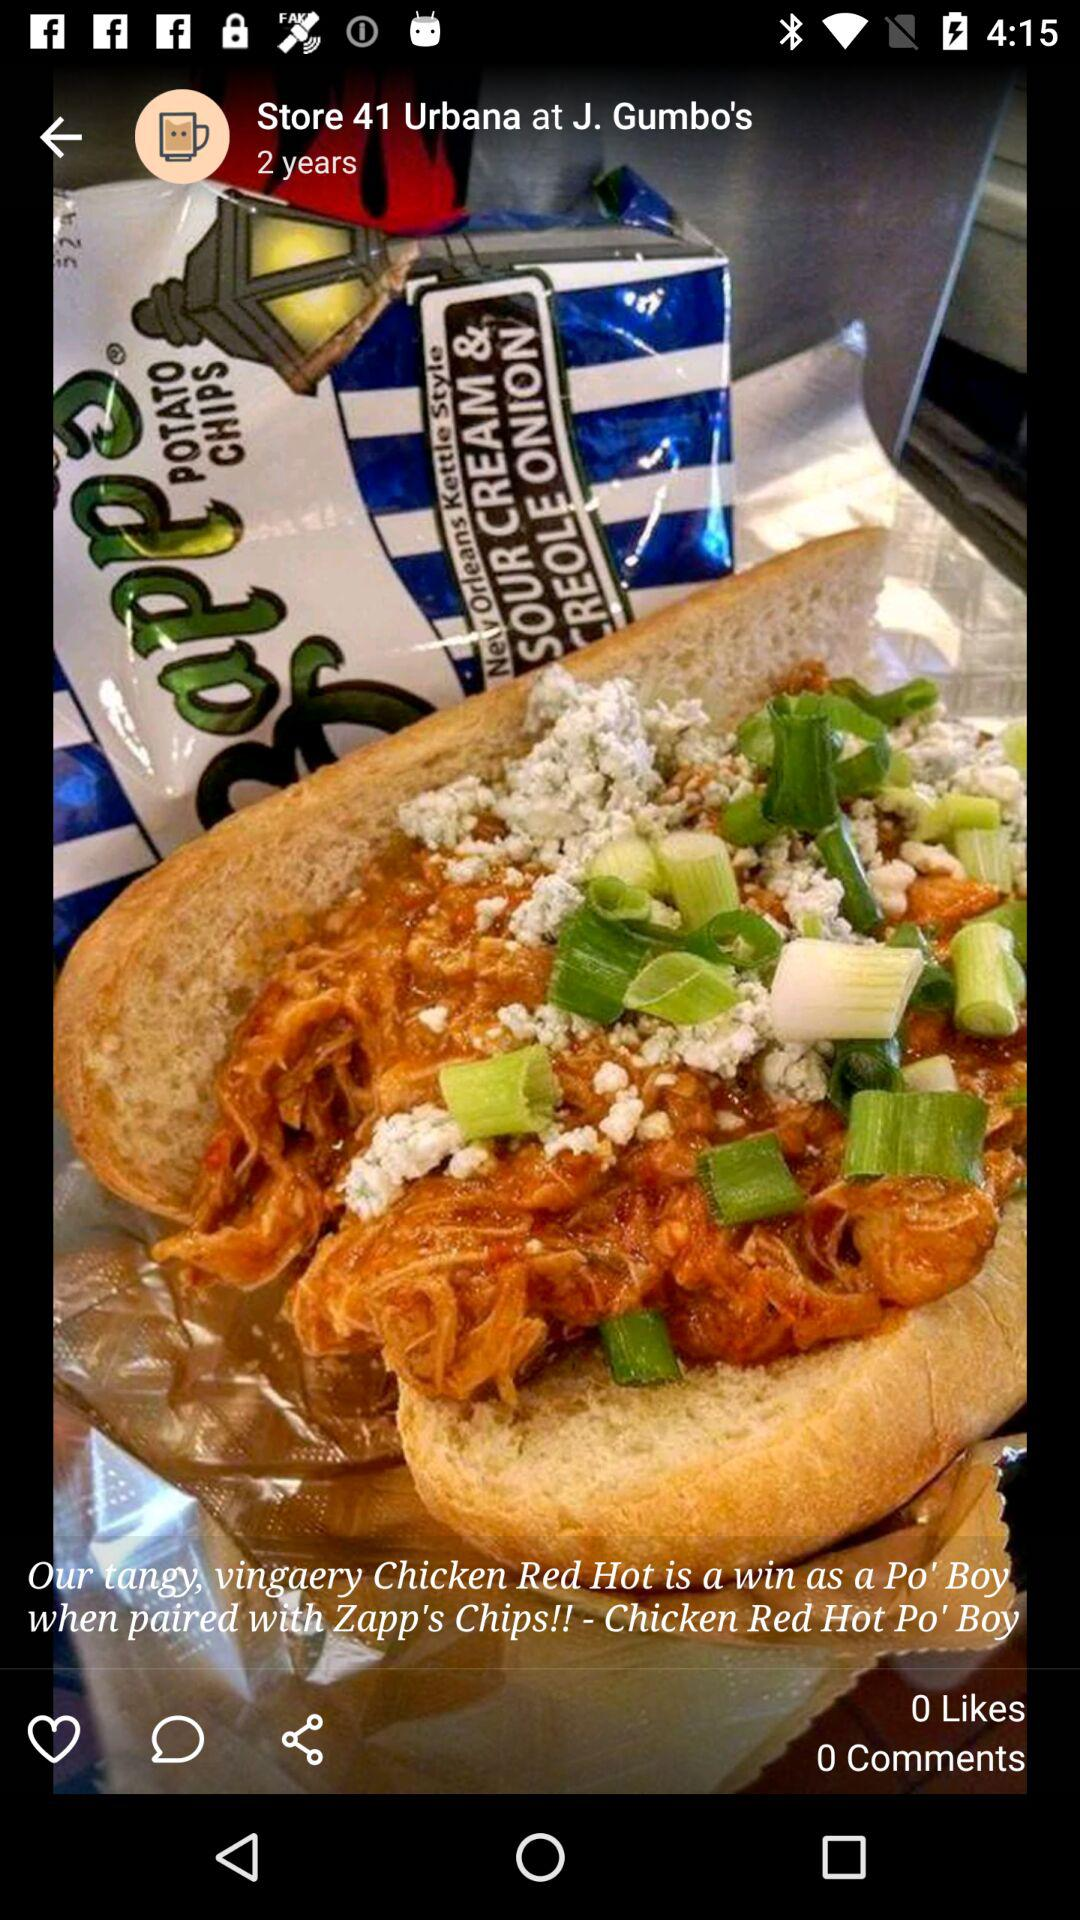How many comments are there? There are 0 comments. 